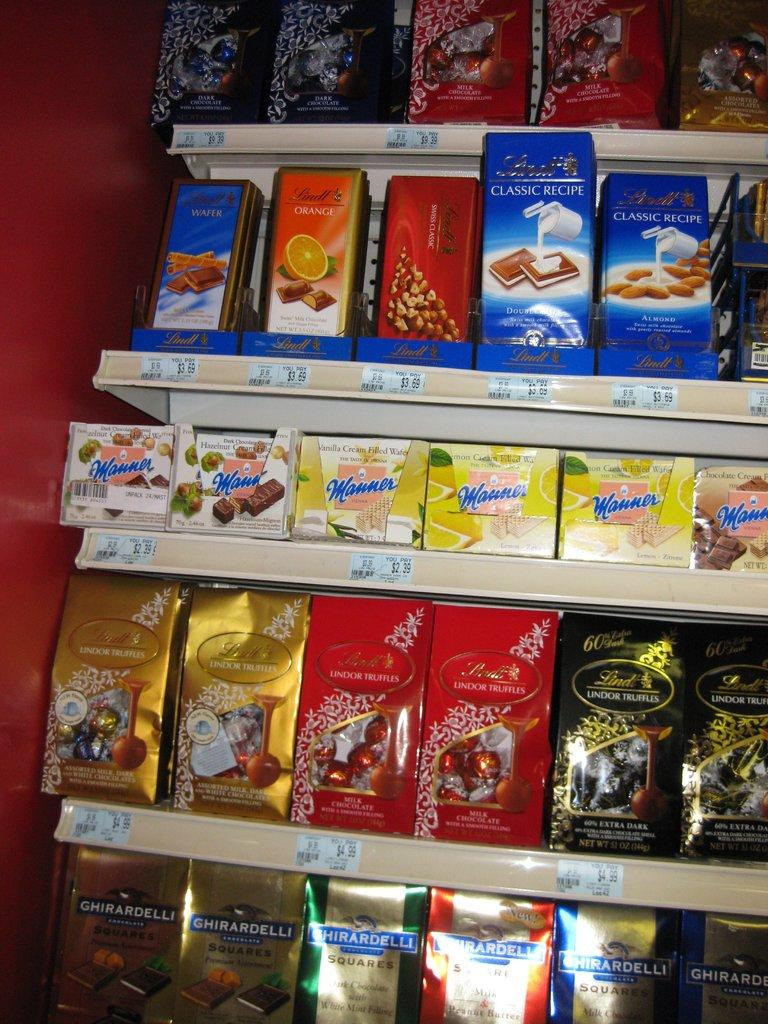What type of items can be seen on the shelves in the image? There are food products in the shelves. Can you describe any other part of the image besides the shelves? Yes, there is a part of the wall visible beside the shelves. How does the wall say good-bye to the person taking the picture? The wall does not have the ability to say good-bye or communicate in any way, as it is an inanimate object. 